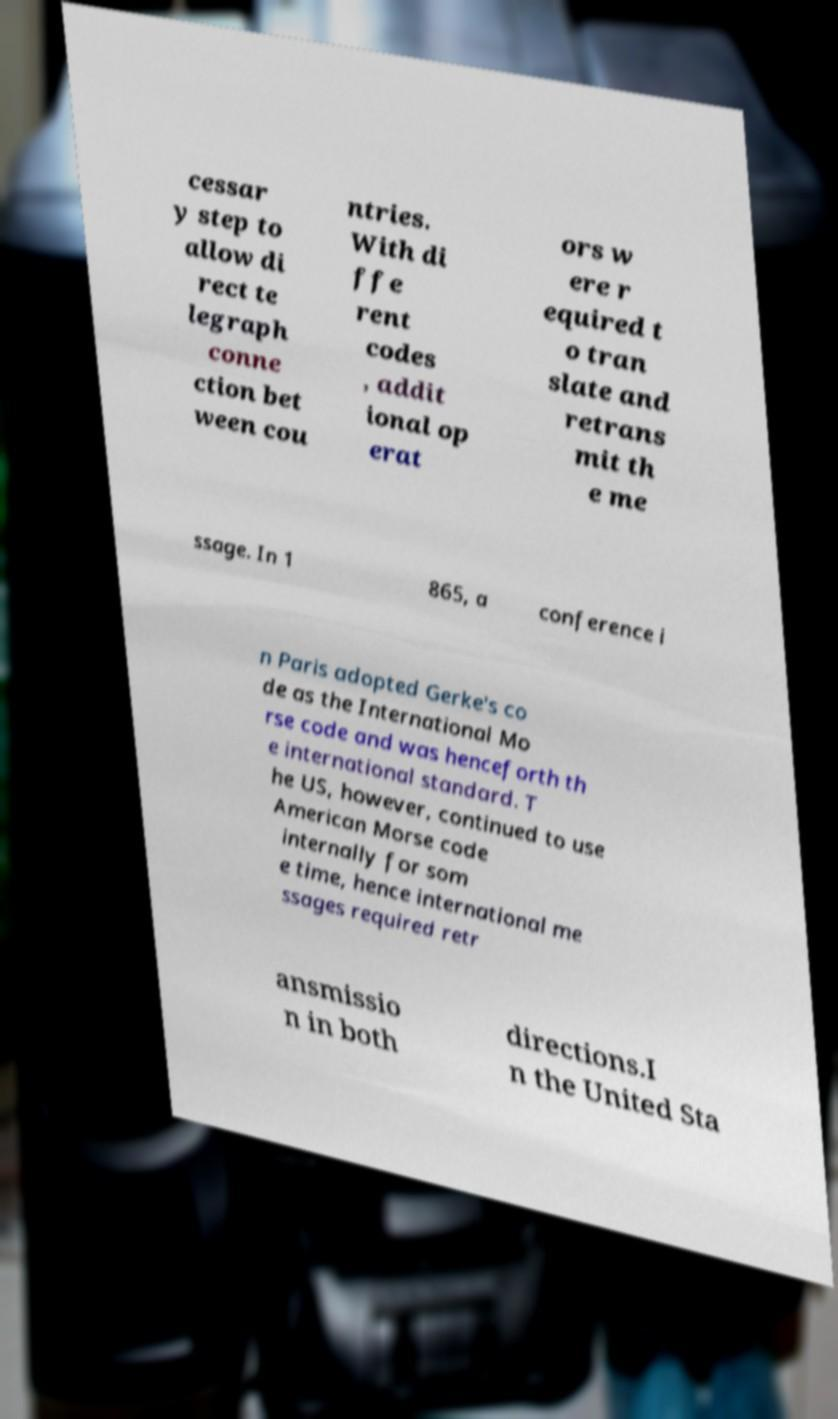Please read and relay the text visible in this image. What does it say? cessar y step to allow di rect te legraph conne ction bet ween cou ntries. With di ffe rent codes , addit ional op erat ors w ere r equired t o tran slate and retrans mit th e me ssage. In 1 865, a conference i n Paris adopted Gerke's co de as the International Mo rse code and was henceforth th e international standard. T he US, however, continued to use American Morse code internally for som e time, hence international me ssages required retr ansmissio n in both directions.I n the United Sta 